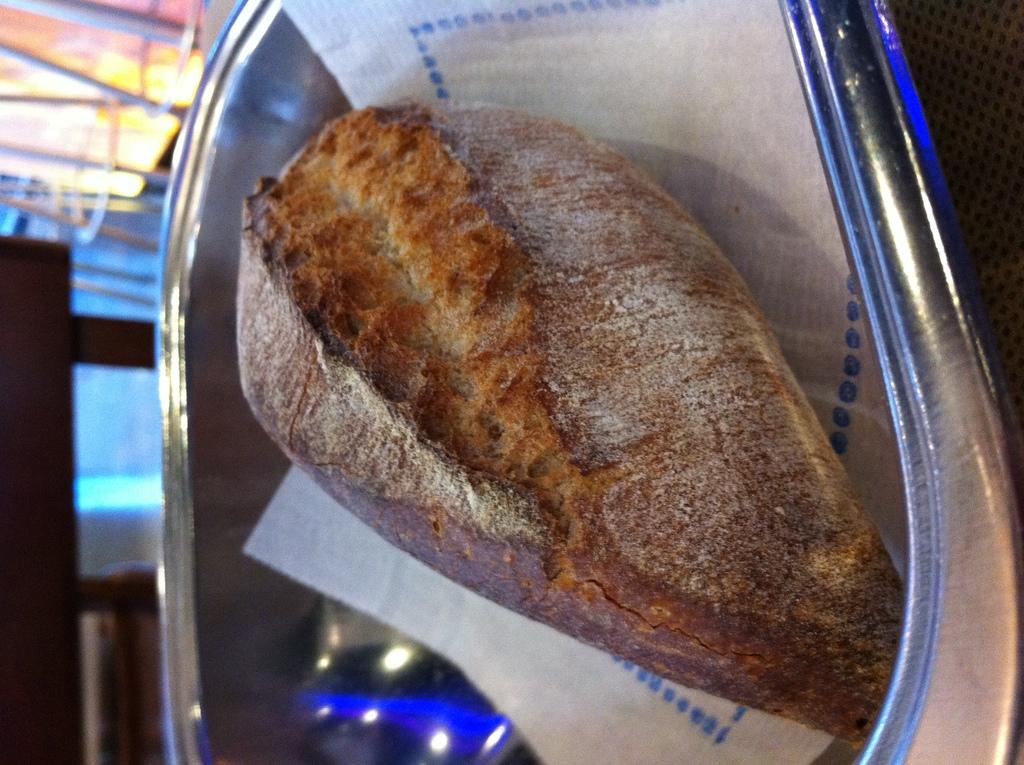What is in the bowl that is visible in the image? There is food in a bowl in the image. What else is in a bowl in the image? There is tissue in a bowl in the image. What objects are on the table in the image? There are glasses on a table in the image. What feeling does the tissue evoke in the image? The tissue itself does not evoke any feeling; it is an inanimate object. 